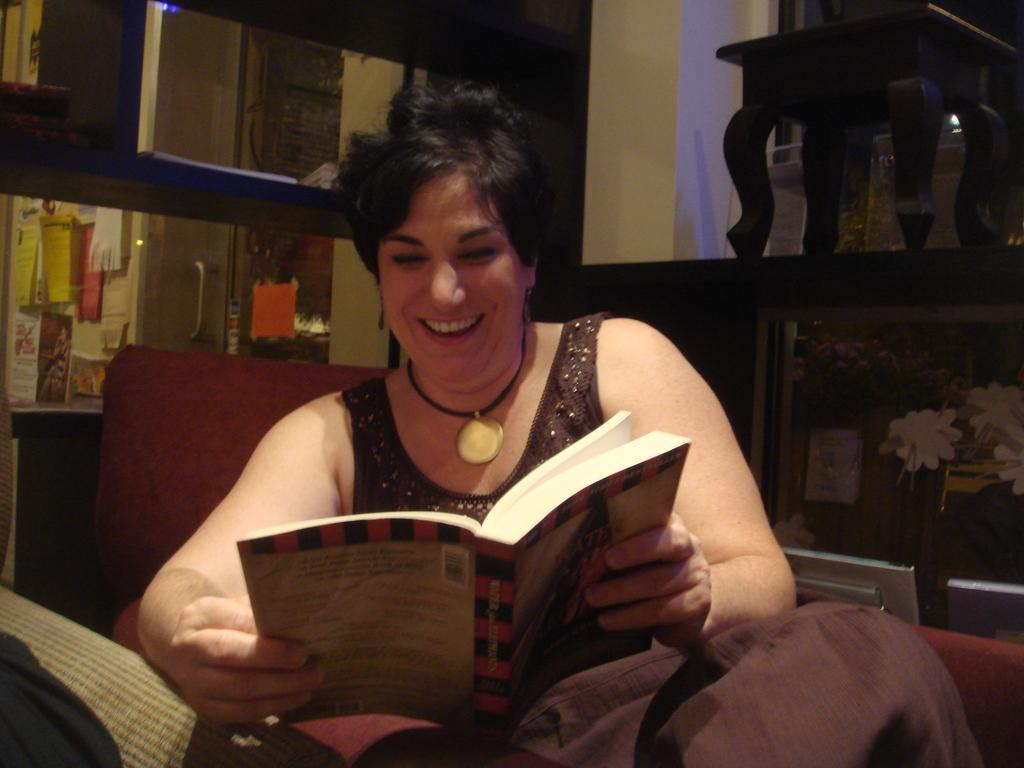Who is present in the image? There is a woman in the image. What is the woman doing in the image? The woman is sitting on a chair in the image. What is the woman holding in the image? The woman is holding a book in the image. What can be seen in the background of the image? There is a wall and a shelf in the background of the image. How many waves can be seen crashing on the shore in the image? There are no waves present in the image; it features a woman sitting on a chair holding a book. What type of agreement was reached between the two parties in the image? There is no indication of any agreement or interaction between parties in the image, as it only shows a woman sitting on a chair holding a book. 